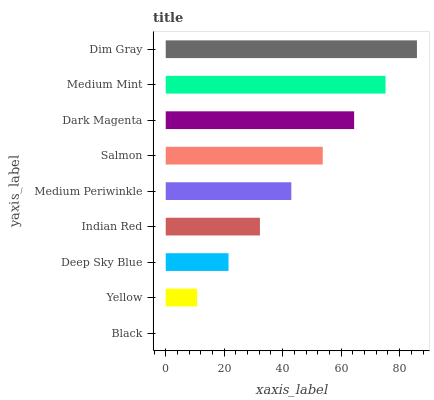Is Black the minimum?
Answer yes or no. Yes. Is Dim Gray the maximum?
Answer yes or no. Yes. Is Yellow the minimum?
Answer yes or no. No. Is Yellow the maximum?
Answer yes or no. No. Is Yellow greater than Black?
Answer yes or no. Yes. Is Black less than Yellow?
Answer yes or no. Yes. Is Black greater than Yellow?
Answer yes or no. No. Is Yellow less than Black?
Answer yes or no. No. Is Medium Periwinkle the high median?
Answer yes or no. Yes. Is Medium Periwinkle the low median?
Answer yes or no. Yes. Is Salmon the high median?
Answer yes or no. No. Is Dim Gray the low median?
Answer yes or no. No. 